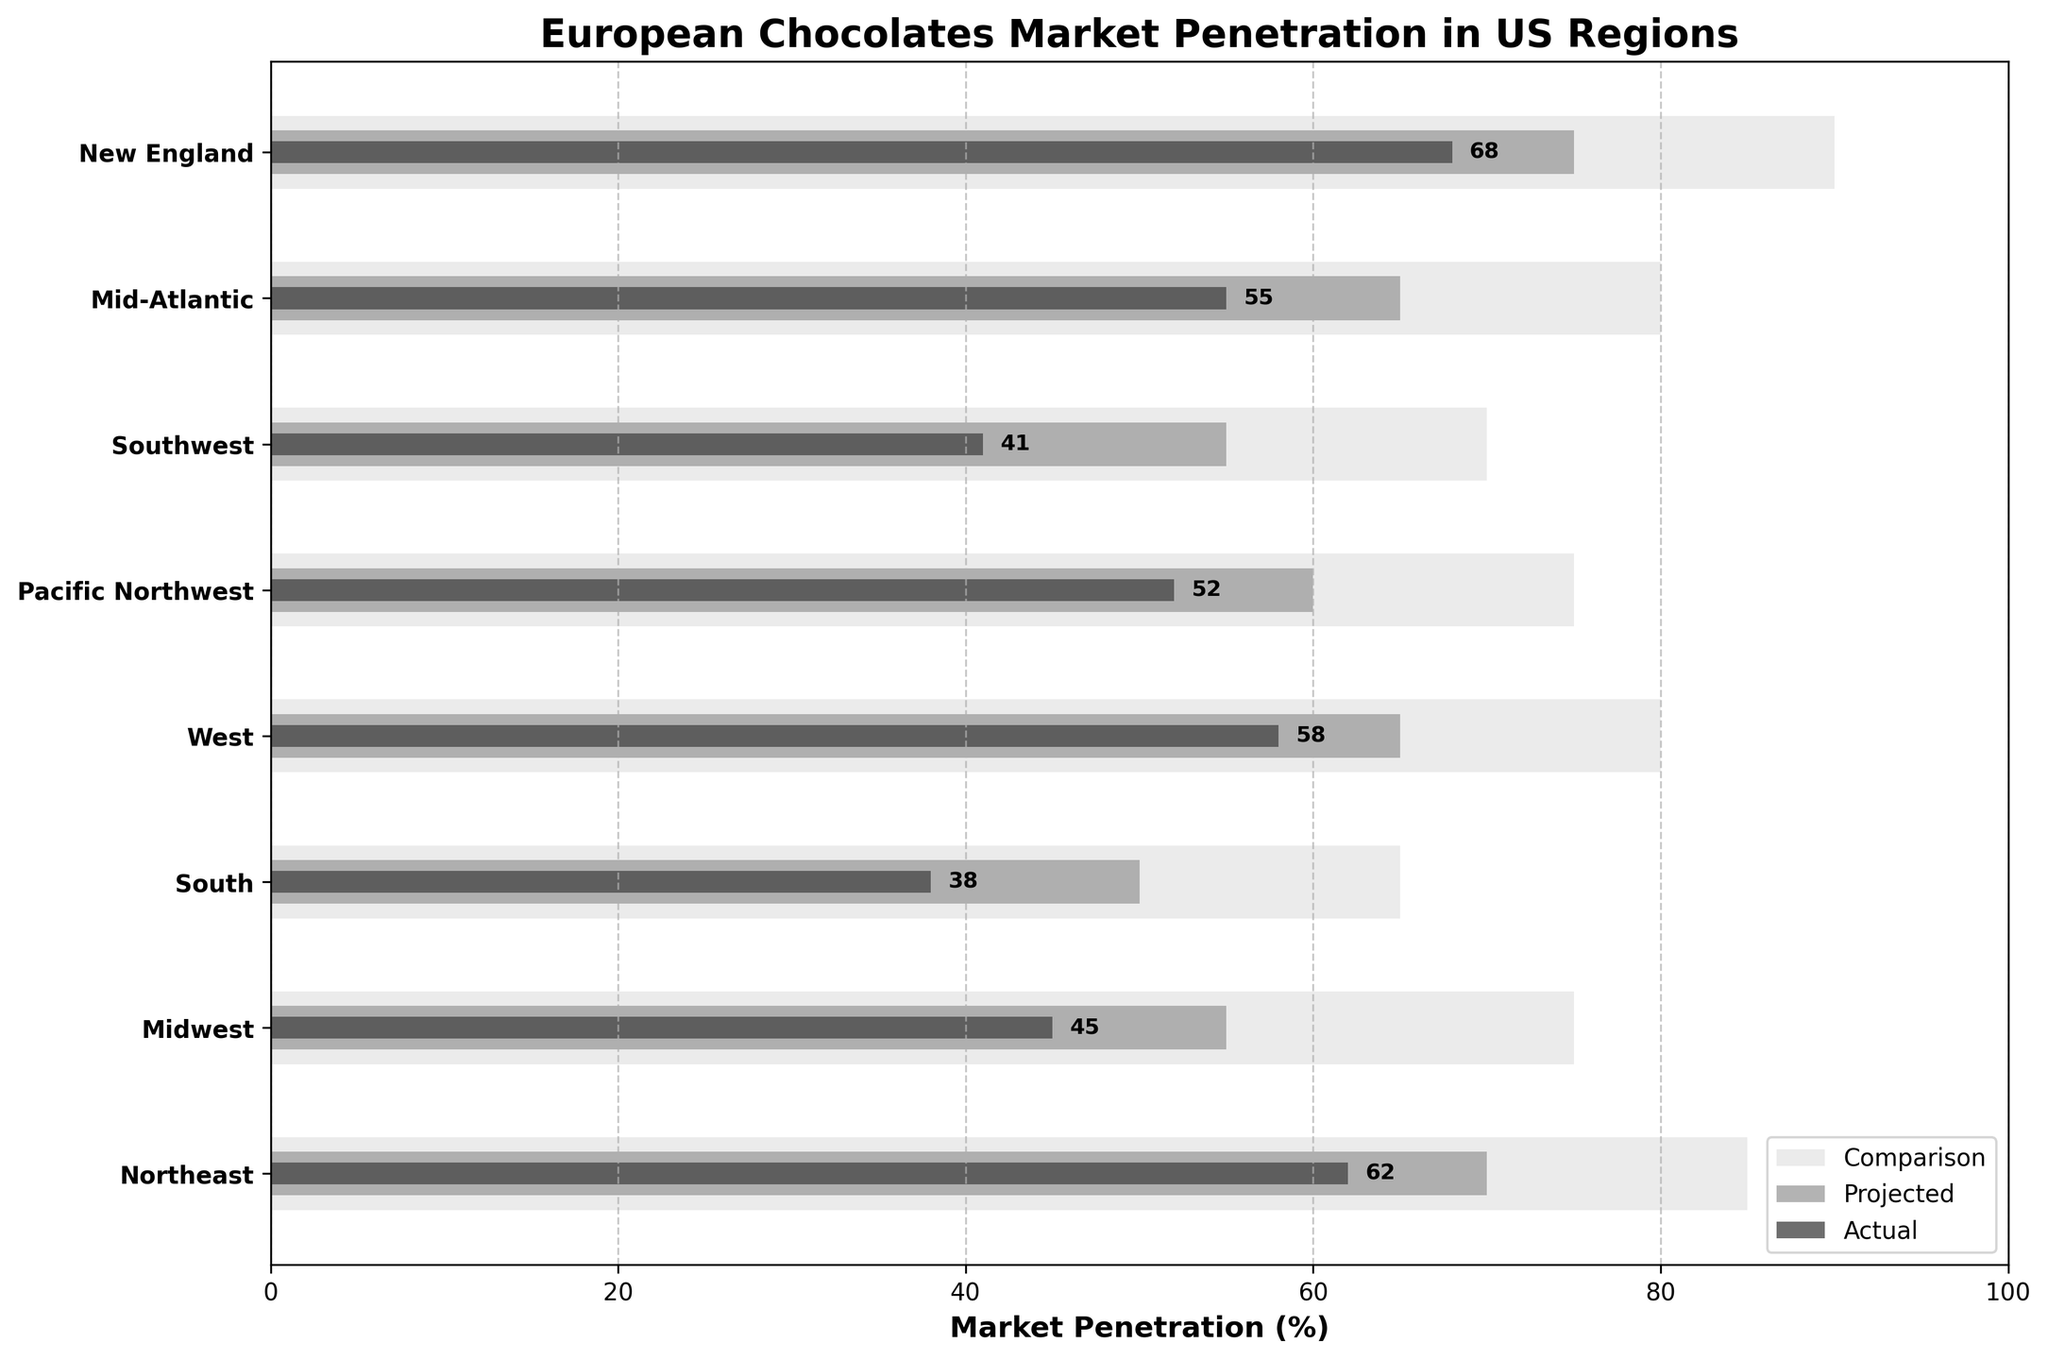What is the highest market penetration rate in the actual data? By examining the heights of the "Actual" bars, we can see which bar reaches the highest value. The "New England" region has the tallest bar in the "Actual" category.
Answer: 68 Which region has the smallest gap between actual and projected market penetration? Calculate the difference between the projected and actual values for each region: Northeast (8), Midwest (10), South (12), West (7), Pacific Northwest (8), Southwest (14), Mid-Atlantic (10), New England (7). The smallest gap is 7, observed in the West and New England regions.
Answer: West and New England How much higher is the comparison value for the South region than its actual value? The "South" region has an actual market penetration of 38% and a comparison value of 65%. Subtract the actual value from the comparison value (65 - 38).
Answer: 27 Which region's projected value is closest to the actual value of the Pacific Northwest? The actual value of the Pacific Northwest is 52. The projected values are 70 (Northeast), 55 (Midwest), 50 (South), 65 (West), 60 (Pacific Northwest), 55 (Southwest), 65 (Mid-Atlantic), and 75 (New England). The closest value is 55, which belongs to the Midwest and Southwest regions.
Answer: Midwest and Southwest Do any regions meet or exceed the forecasted market penetration? The actual values for all regions are: Northeast (62), Midwest (45), South (38), West (58), Pacific Northwest (52), Southwest (41), Mid-Atlantic (55), New England (68). Compare these with the projected values: Northeast (70), Midwest (55), South (50), West (65), Pacific Northwest (60), Southwest (55), Mid-Atlantic (65), New England (75). No region's actual value meets or exceeds its projected value.
Answer: No How does the market penetration in the Northeast compare to the Pacific Northwest? Compare the actual, projected, and comparison values for both regions: Northeast (Actual: 62, Projected: 70, Comparison: 85), and Pacific Northwest (Actual: 52, Projected: 60, Comparison: 75). The Northeast has higher actual, projected, and comparison values than the Pacific Northwest.
Answer: The Northeast is higher in all aspects What is the average actual market penetration across all regions? Add the actual values: 62 (Northeast), 45 (Midwest), 38 (South), 58 (West), 52 (Pacific Northwest), 41 (Southwest), 55 (Mid-Atlantic), 68 (New England). The total is 419. Divide by the number of regions (8).
Answer: 52.375 Which region has the largest discrepancy between its actual and comparison values? Compute the difference between comparison and actual values: Northeast (23), Midwest (30), South (27), West (22), Pacific Northwest (23), Southwest (29), Mid-Atlantic (25), New England (22). The Midwest has the largest discrepancy at 30.
Answer: Midwest 